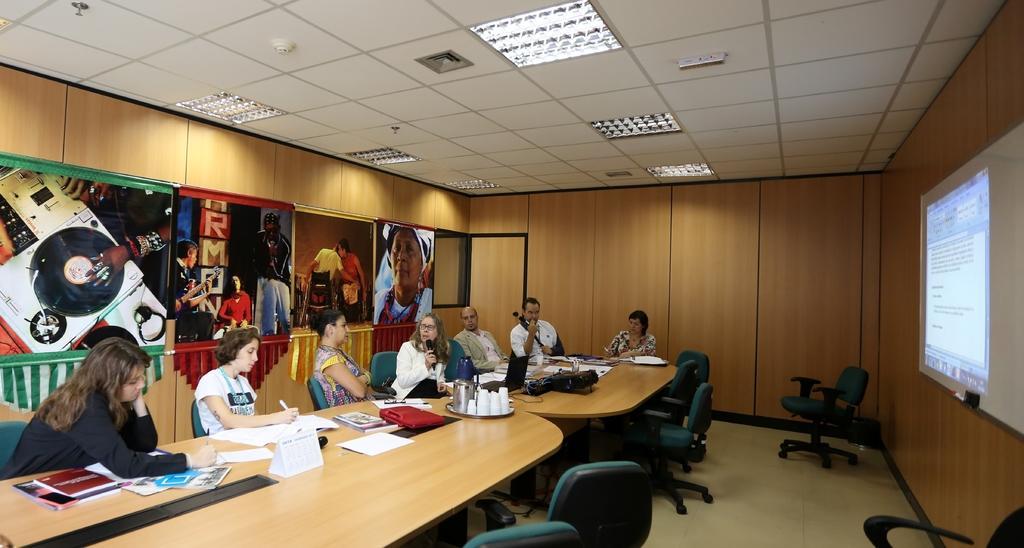Please provide a concise description of this image. On a wall there are different type of pictures. This persons are sitting on a chair. This woman and this man are holding a mic. On a table there is a plate, jar, cups and book. Light is attached with roof. This is screen. 